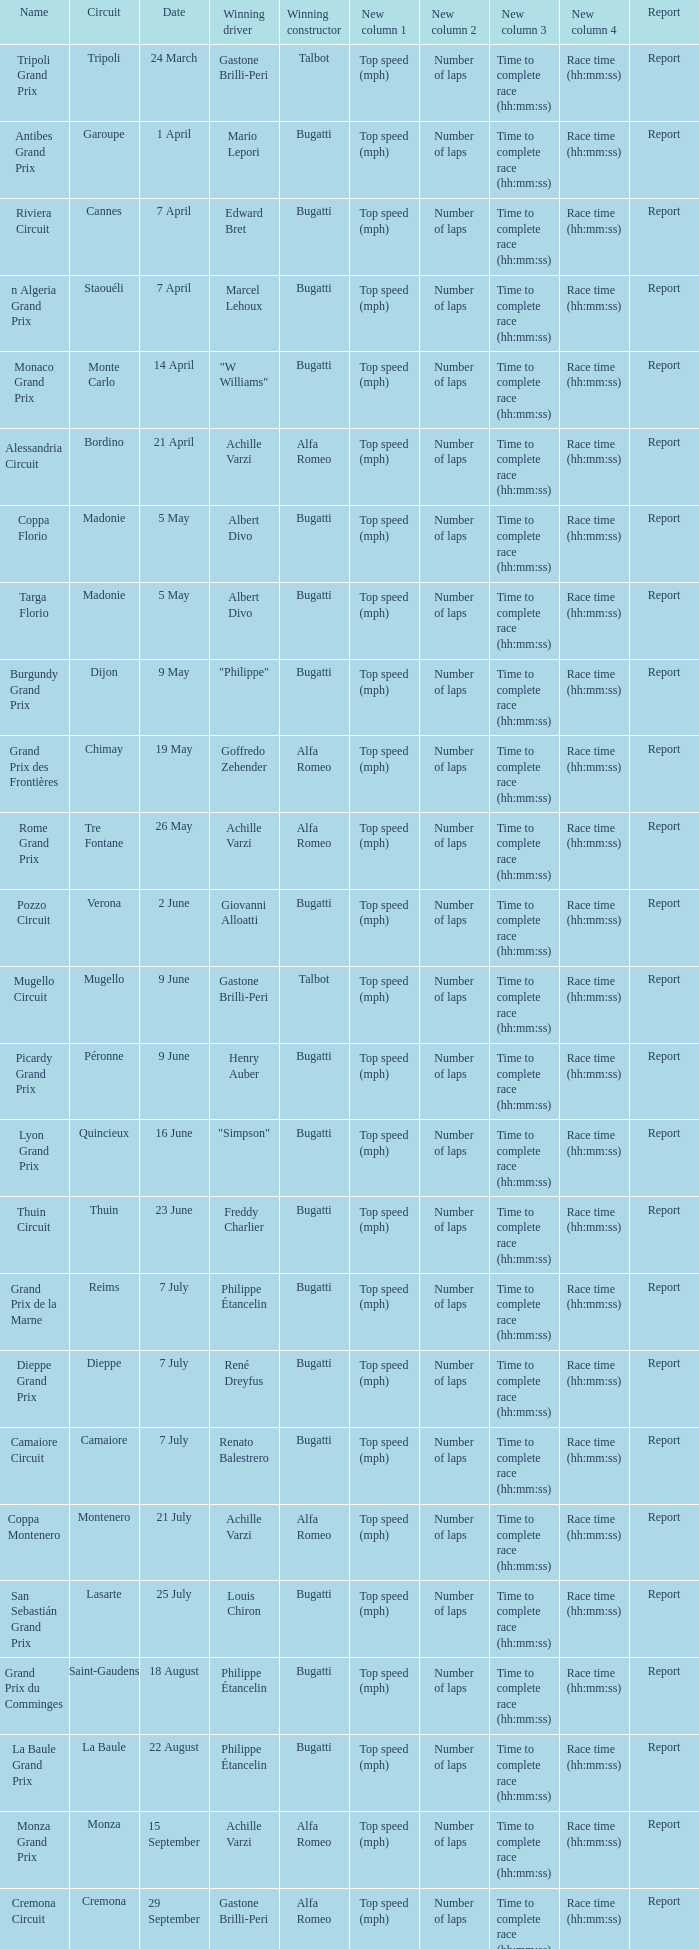What Circuit has a Date of 25 july? Lasarte. 